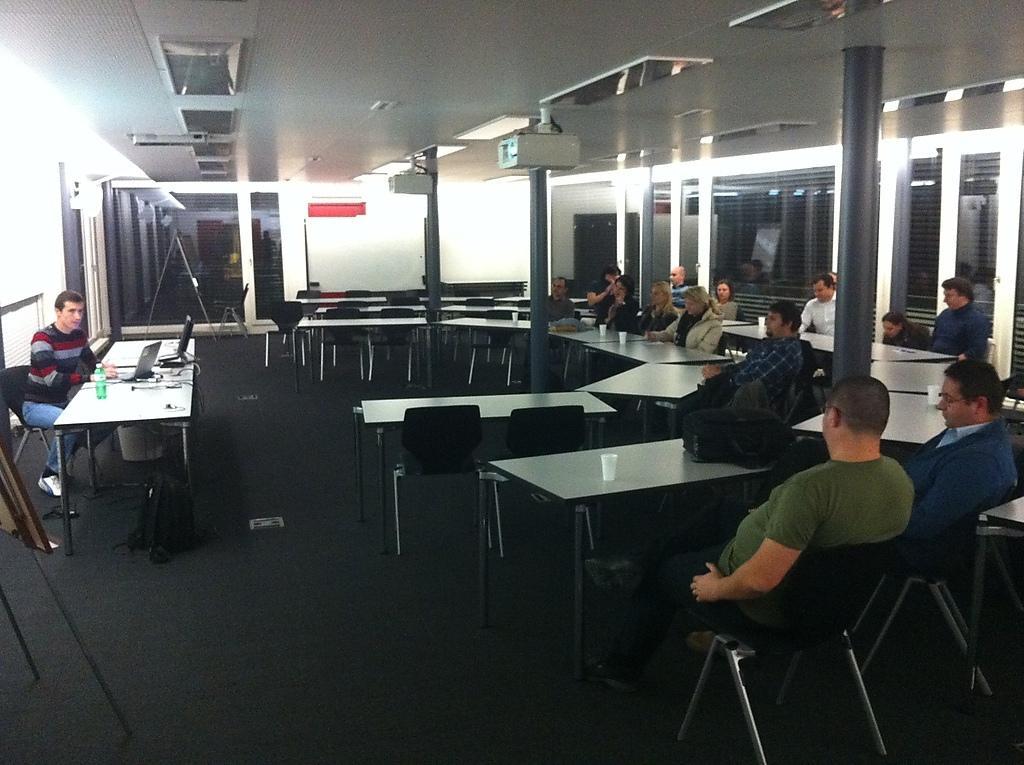In one or two sentences, can you explain what this image depicts? There are group of persons sitting on the chairs in the room 